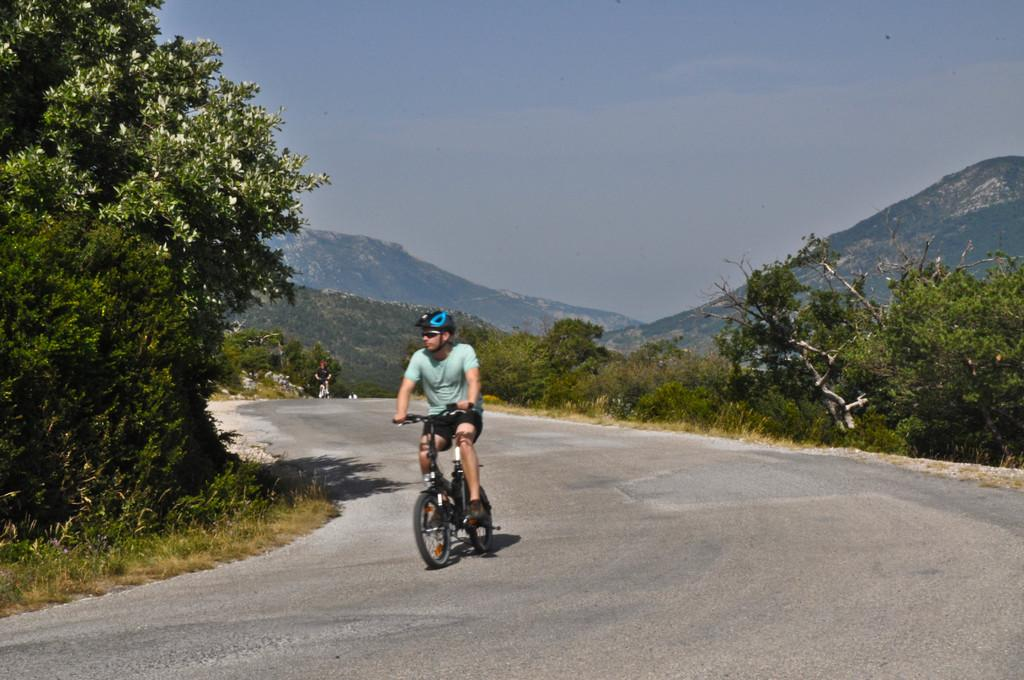What is the main subject of the image? There is a person riding a bicycle in the image. What safety precaution is the person taking while riding the bicycle? The person is wearing a helmet. What can be seen in the background of the image? There are trees and hills in the background of the image. Are there any other people visible in the image? Yes, there is another person in the background of the image. What type of alarm is the person riding the bicycle using in the image? There is no alarm present in the image; the person is simply riding a bicycle. What type of cabbage is growing on the hills in the background of the image? There is no cabbage present in the image; the hills in the background are covered with vegetation, but no specific plants are mentioned. 